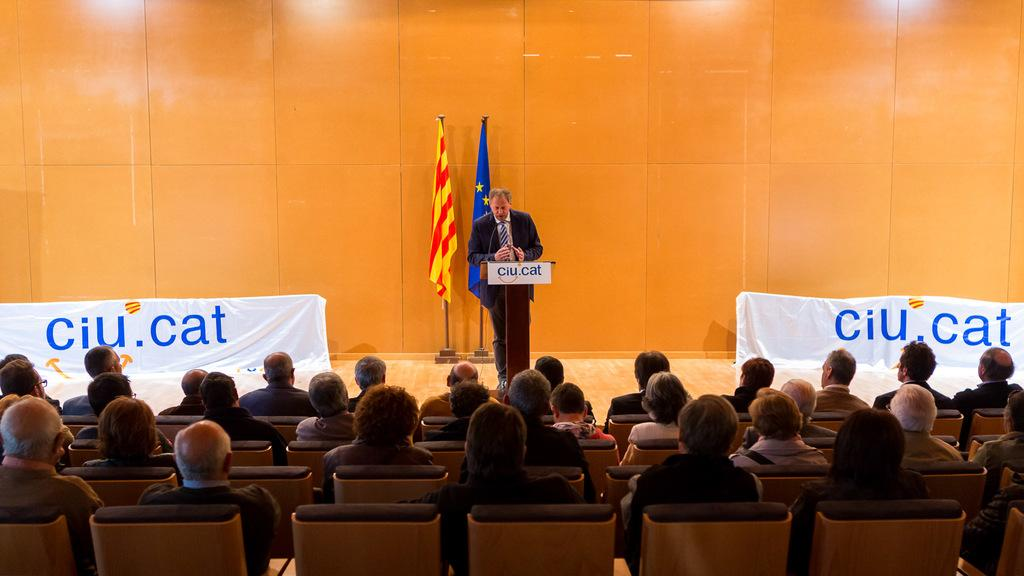How many people are in the image? There is a group of people in the image. What are the people in the image doing? The people are sitting. What can be seen on the stage in the image? There is a man standing at a podium on a stage. What are the people doing in relation to the man on the stage? The people are listening to the man. What type of farm animals can be seen grazing in the image? There is no farm or farm animals present in the image. How does the sun affect the people's ability to see the man on the stage? The image does not provide information about the sun or its effect on visibility, as it only shows the people sitting and the man on the stage. 